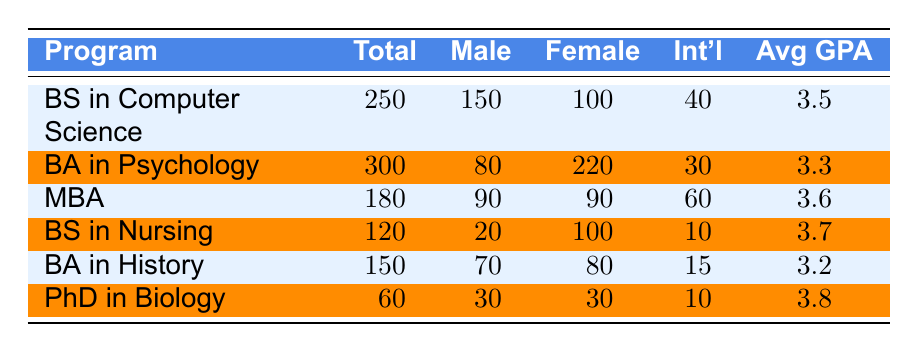What is the total enrollment for the Bachelor of Science in Computer Science program? The table shows that the total enrollment for the Bachelor of Science in Computer Science program is listed under the "Total" column at 250.
Answer: 250 How many female students are enrolled in the Bachelor of Arts in Psychology program? The Bachelor of Arts in Psychology program has its female student count listed in the table, which shows there are 220 female students.
Answer: 220 What is the average GPA of students enrolled in the Master of Business Administration program? The average GPA for the Master of Business Administration program is indicated in the "Avg GPA" column, which shows an average GPA of 3.6.
Answer: 3.6 How many international students are enrolled in the Bachelor of Science in Nursing program? The table shows that there are 10 international students enrolled in the Bachelor of Science in Nursing program, under the "Int'l" column.
Answer: 10 What is the total number of male students across all programs? To find the total number of male students, we add the male student counts from all programs: 150 (CS) + 80 (Psychology) + 90 (MBA) + 20 (Nursing) + 70 (History) + 30 (Biology) = 440 male students in total.
Answer: 440 Which program has the highest number of total enrollment? By checking the "Total" column, the Bachelor of Arts in Psychology is listed with 300 total enrollments, which is higher than any other program.
Answer: Bachelor of Arts in Psychology What is the difference in total enrollment between the Bachelor of Science in Computer Science and the Bachelor of Science in Nursing? The total enrollment for the Bachelor of Science in Computer Science is 250 and for the Bachelor of Science in Nursing it is 120. The difference is 250 - 120 = 130.
Answer: 130 How many programs have an average GPA above 3.5? Looking at the "Avg GPA" column, the programs with an average GPA above 3.5 are: BS in Computer Science (3.5), MBA (3.6), BS in Nursing (3.7), and PhD in Biology (3.8). Therefore, there are 3 programs with an average GPA above 3.5.
Answer: 3 Is the number of female students in the Bachelor of Arts in History greater than that in the Bachelor of Science in Nursing? The Bachelor of Arts in History has 80 female students, and the Bachelor of Science in Nursing has 100 female students listed in the table. Since 80 is not greater than 100, the statement is false.
Answer: No What proportion of students enrolled in the MBA program are international students? The total enrollment for the MBA is 180, and there are 60 international students. The proportion is 60/180 = 1/3, which simplifies to approximately 0.33 or 33%.
Answer: 33% Which program has the same number of male and female students? In the table, the Master of Business Administration program has an equal count of male and female students, with 90 males and 90 females.
Answer: Master of Business Administration 